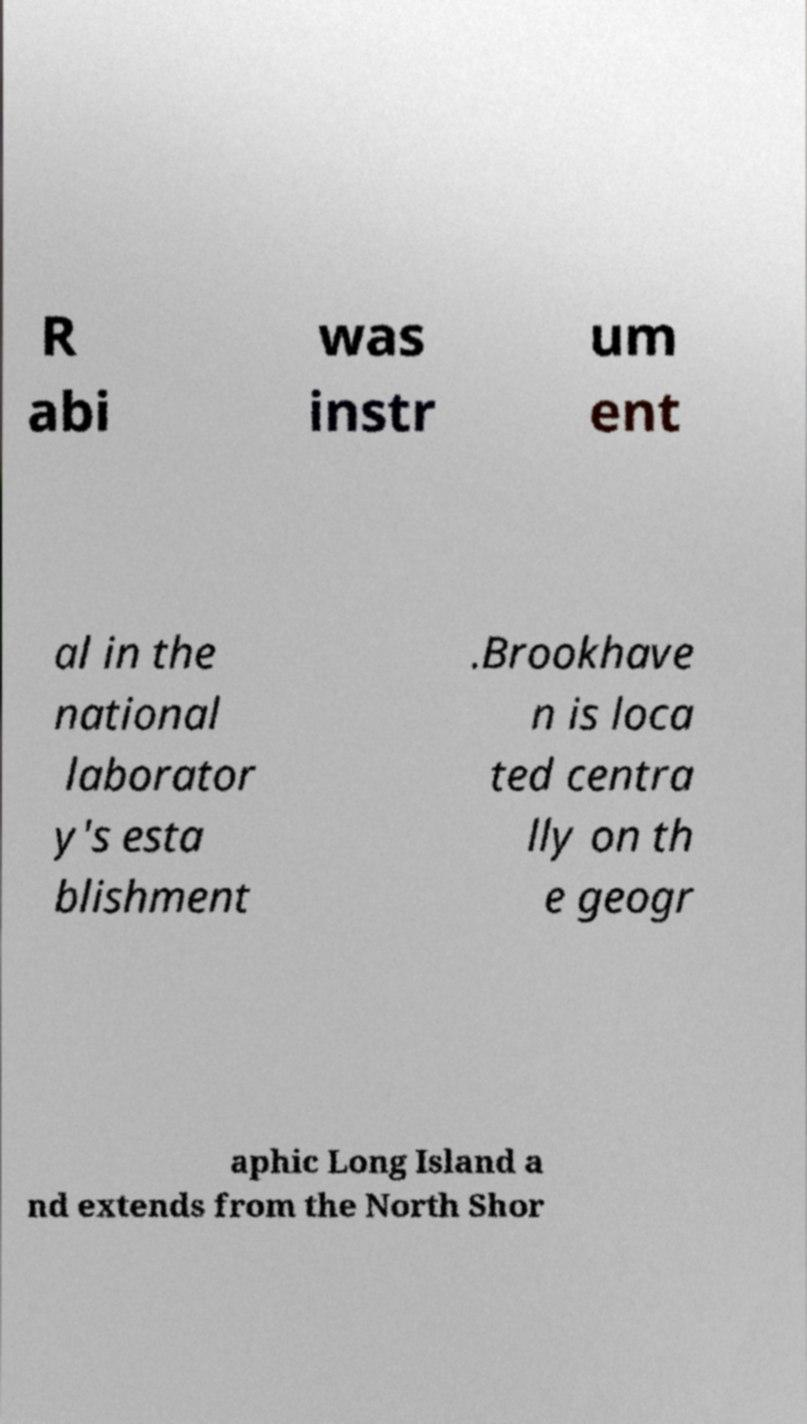For documentation purposes, I need the text within this image transcribed. Could you provide that? R abi was instr um ent al in the national laborator y's esta blishment .Brookhave n is loca ted centra lly on th e geogr aphic Long Island a nd extends from the North Shor 